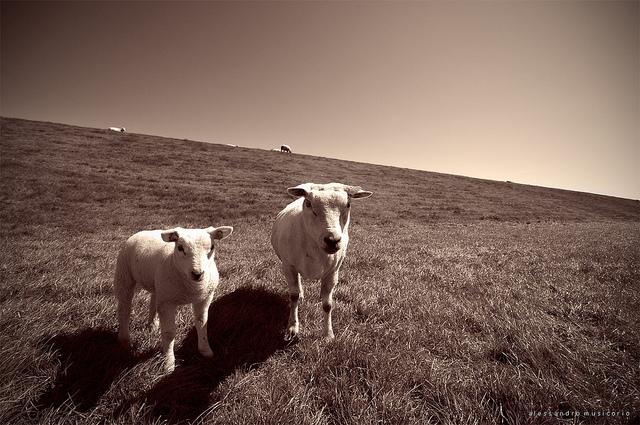Does the sheep have a shadow on the ground?
Short answer required. Yes. What spices are the animals?
Be succinct. Sheep. What animal do you see?
Keep it brief. Sheep. Where is the reflection?
Short answer required. To left. Are the animals all the same color?
Write a very short answer. Yes. What color effect has been applied to this photo?
Short answer required. Black and white. Is the grass green?
Short answer required. No. How many animals are in this photo?
Keep it brief. 4. 